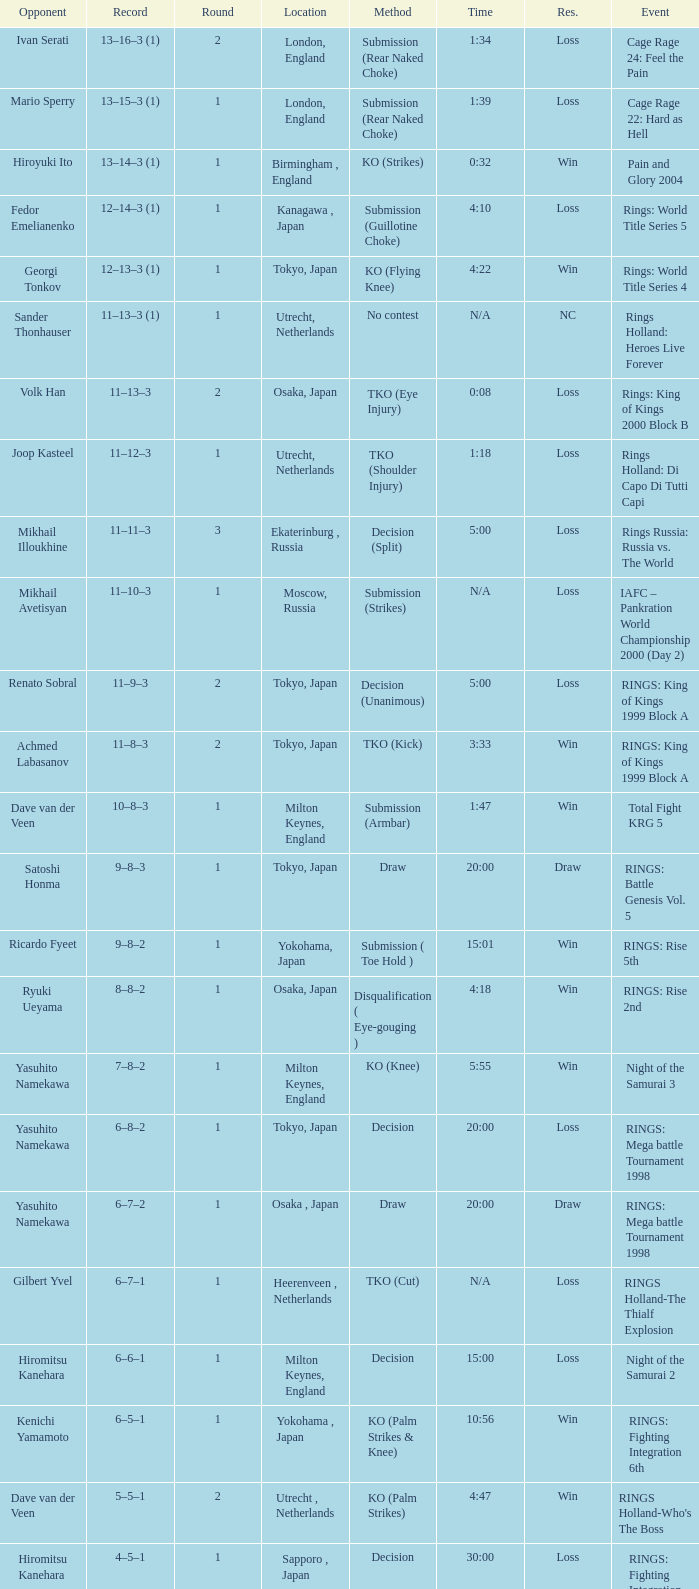What is the time for an opponent of Satoshi Honma? 20:00. 